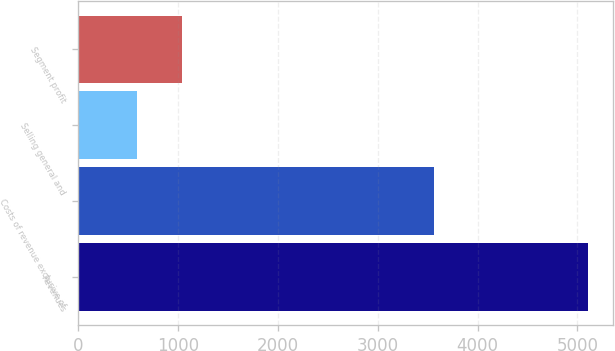Convert chart to OTSL. <chart><loc_0><loc_0><loc_500><loc_500><bar_chart><fcel>Revenues<fcel>Costs of revenue exclusive of<fcel>Selling general and<fcel>Segment profit<nl><fcel>5105<fcel>3566<fcel>582<fcel>1034.3<nl></chart> 